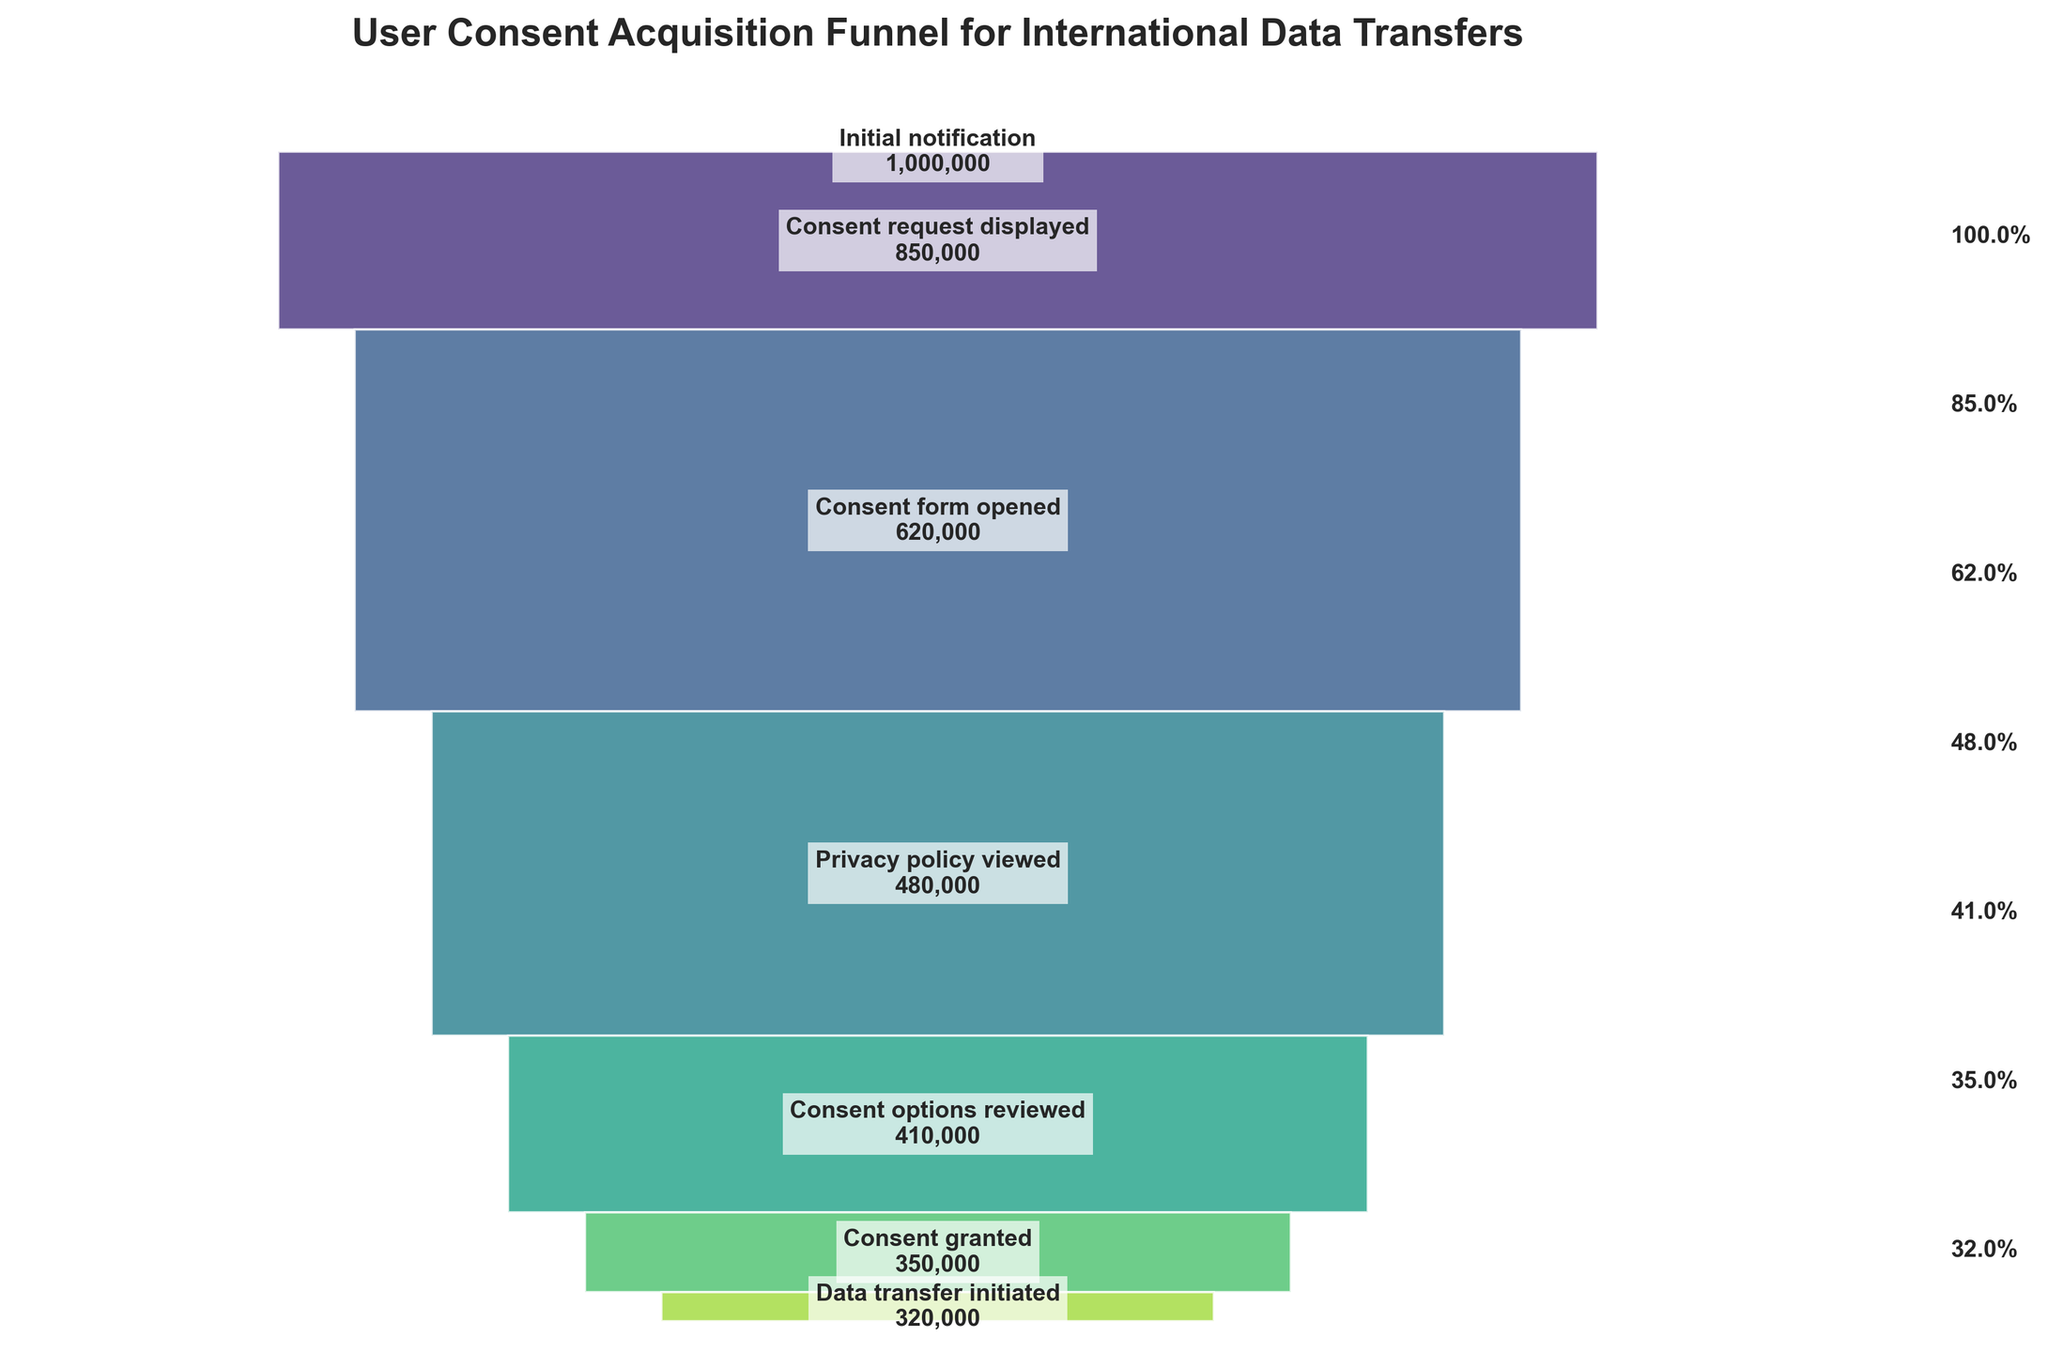What's the title of the figure? The title is typically placed at the top of the figure. It should be clear and descriptive to indicate what the figure represents.
Answer: User Consent Acquisition Funnel for International Data Transfers How many stages are there in the funnel? By counting the distinct segments in the funnel chart, we identify the number of stages.
Answer: 7 What is the percentage of users who granted consent relative to the initial notification? To find this, divide the number of users who granted consent (350,000) by the number of users who received the initial notification (1,000,000), then multiply by 100 to convert to a percentage.
Answer: 35% Which stage has the highest dropout rate? The dropout rate can be calculated by the difference in the number of users between two consecutive stages. By comparing these differences, the highest dropout rate is observed between the 'Consent request displayed' (850,000) and 'Consent form opened' (620,000) stages.
Answer: Consent request displayed to Consent form opened Percentage-wise, what proportion of users viewed the privacy policy compared to those who opened the consent form? This involves dividing the number of users who viewed the privacy policy (480,000) by those who opened the consent form (620,000) and multiplying by 100 to convert to a percentage.
Answer: 77.4% Which stage has the smallest percentage drop from the previous stage? Calculate the percentage drop for each transition by dividing the difference between consecutive stages by the higher stage figure and compare. The smallest percentage drop is between 'Privacy policy viewed' and 'Consent options reviewed'.
Answer: Privacy policy viewed to Consent options reviewed How many fewer users granted consent compared to those who reviewed consent options? Subtract the number of users who granted consent (350,000) from those who reviewed consent options (410,000).
Answer: 60,000 Which stage is immediately before 'Data transfer initiated'? Identify the stage listed just before ‘Data transfer initiated’ in the funnel stages sequence.
Answer: Consent granted What's the reduction rate in users from 'Initial notification' to 'Consent request displayed'? Calculate the reduction by subtracting the number of users at 'Consent request displayed' (850,000) from those at 'Initial notification' (1,000,000), then divide by the 'Initial notification' number and multiply by 100 for the percentage.
Answer: 15% What can be inferred if the number of users who viewed the privacy policy was higher than those who opened the consent form? It suggests a missing stage or miscount in data as logically, users must open the consent form before viewing the privacy policy. This inconsistency would challenge data integrity.
Answer: Data discrepancy or integrity issue 